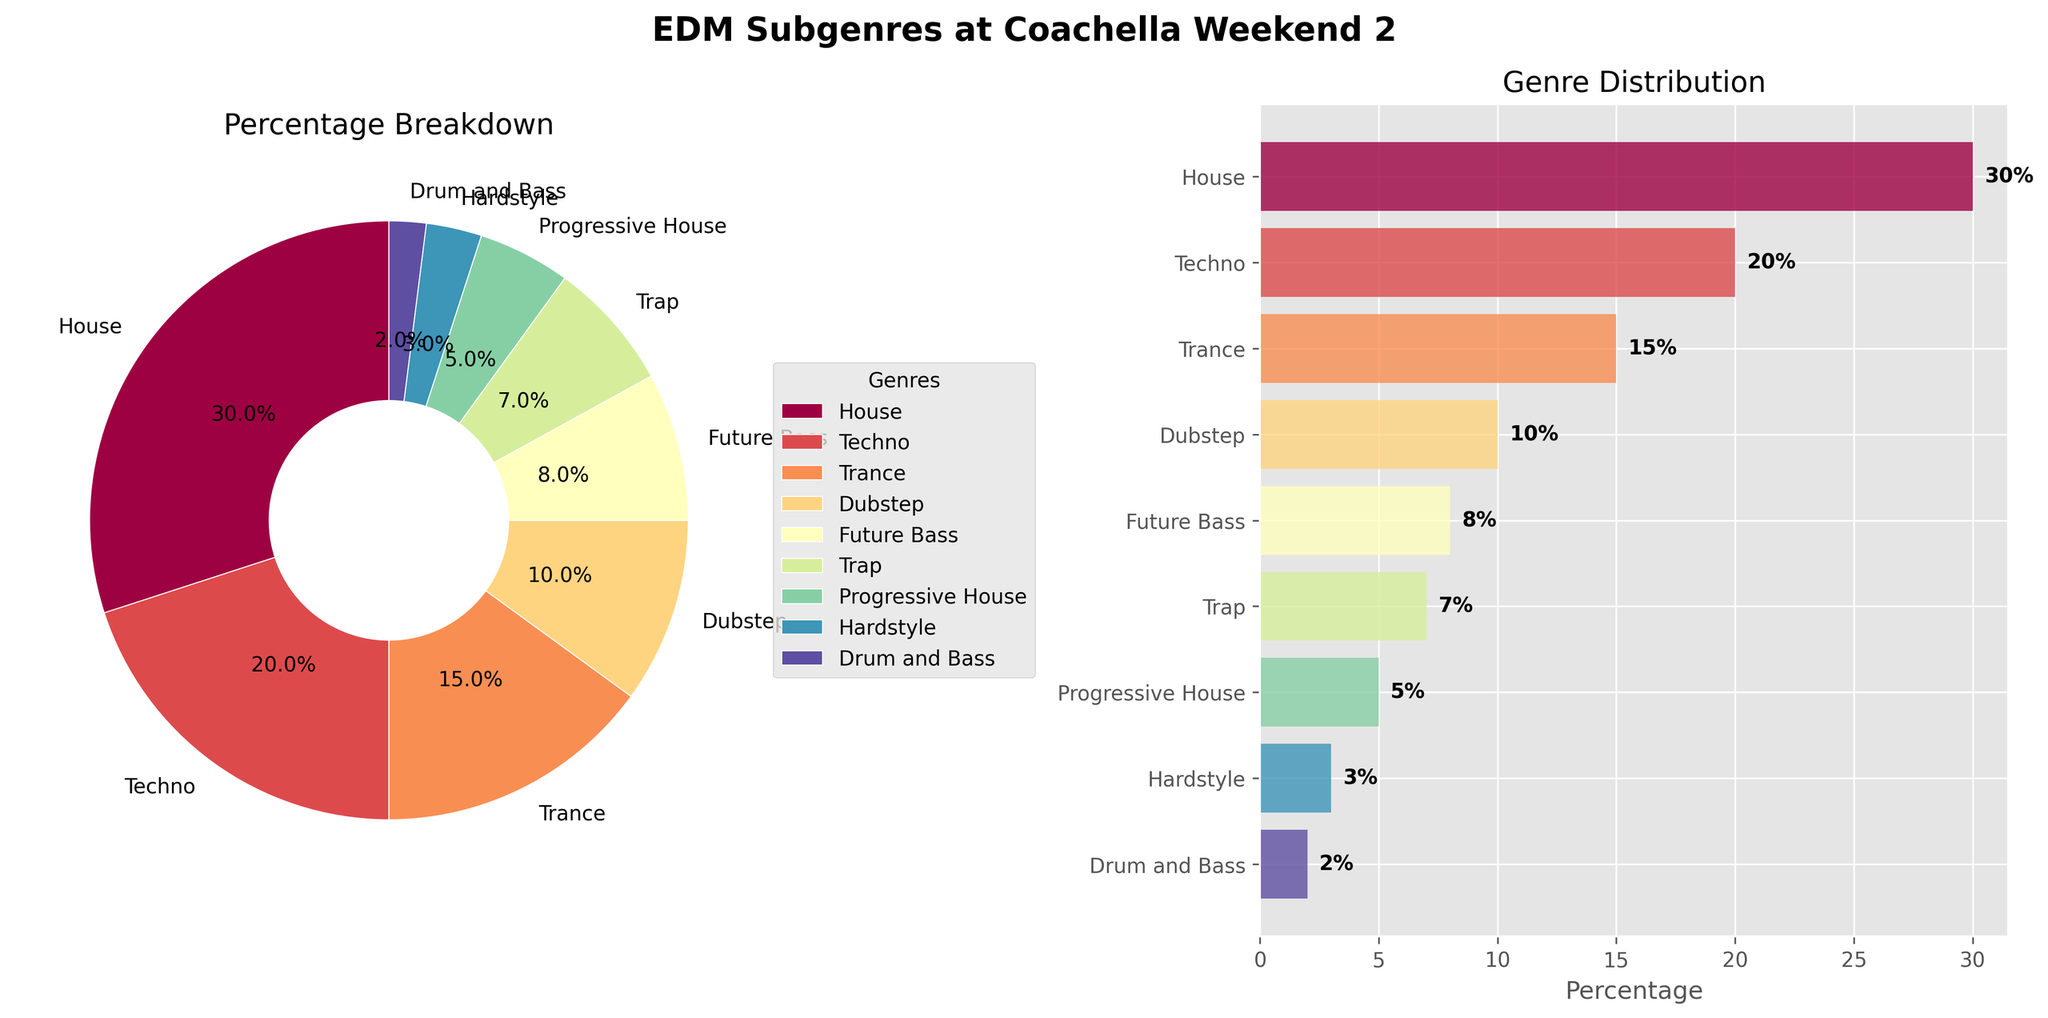What is the title of the subplot? The title of the subplot is prominently displayed above the two charts. It reads "EDM Subgenres at Coachella Weekend 2" in bold text.
Answer: EDM Subgenres at Coachella Weekend 2 Which EDM subgenre constitutes the largest percentage? By observing the pie chart, the largest wedge is labeled and indicates the subgenre "House" which takes up 30% of the chart.
Answer: House What is the combined percentage of Techno and Trance? The percentage of Techno is 20% and Trance is 15%. Adding these percentages together gives 20% + 15% = 35%.
Answer: 35% Which subgenre is represented by the smallest wedge in the pie chart? The smallest wedge in the pie chart represents Drum and Bass, occupying only 2% of the total.
Answer: Drum and Bass How does the percentage of Dubstep compare to Future Bass? Dubstep occupies 10% while Future Bass takes up 8%. By comparing, Dubstep has a higher percentage than Future Bass.
Answer: Dubstep has a higher percentage What are the subgenres with percentages lower than 10%? The subgenres with less than 10% are Future Bass (8%), Trap (7%), Progressive House (5%), Hardstyle (3%), and Drum and Bass (2%).
Answer: Future Bass, Trap, Progressive House, Hardstyle, Drum and Bass How many subgenres are represented in the charts? Counting each labeled wedge in the pie chart or each bar in the bar chart, we see that there are 9 subgenres in total.
Answer: 9 What percentage of the Pie Chart is covered by subgenres other than House? House takes up 30%, so the remaining percentage is 100% - 30% = 70%.
Answer: 70% Which two genres together sum up to more than House's percentage alone? Techno (20%) and Trance (15%) together sum up to 35%, which is greater than House's 30%.
Answer: Techno and Trance What is the average percentage for all subgenres? To find the average percentage, sum all percentages and divide by the number of subgenres: (30+20+15+10+8+7+5+3+2)/9 = 100/9 ≈ 11.1%.
Answer: 11.1% 